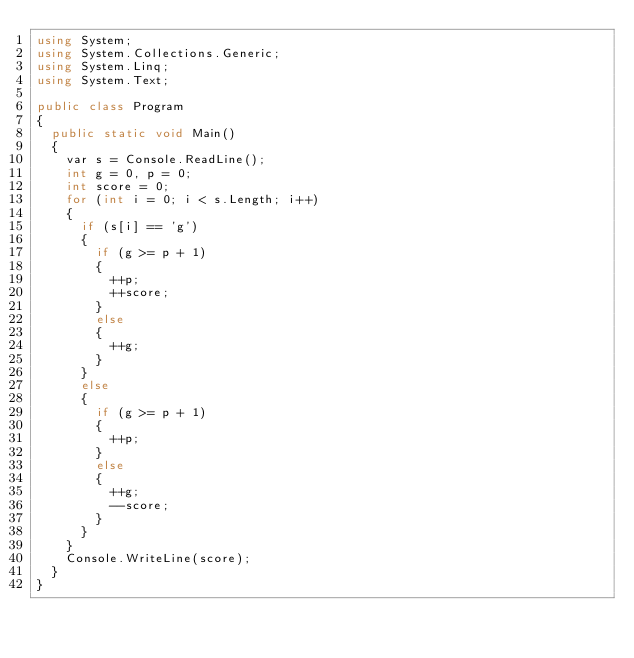<code> <loc_0><loc_0><loc_500><loc_500><_C#_>using System;
using System.Collections.Generic;
using System.Linq;
using System.Text;

public class Program
{
	public static void Main()
	{
		var s = Console.ReadLine();
		int g = 0, p = 0;
		int score = 0;
		for (int i = 0; i < s.Length; i++)
		{
			if (s[i] == 'g')
			{
				if (g >= p + 1)
				{
					++p;
					++score;
				}
				else
				{
					++g;
				}
			}
			else
			{
				if (g >= p + 1)
				{
					++p;
				}
				else
				{
					++g;
					--score;
				}
			}
		}
		Console.WriteLine(score);
	}
}</code> 